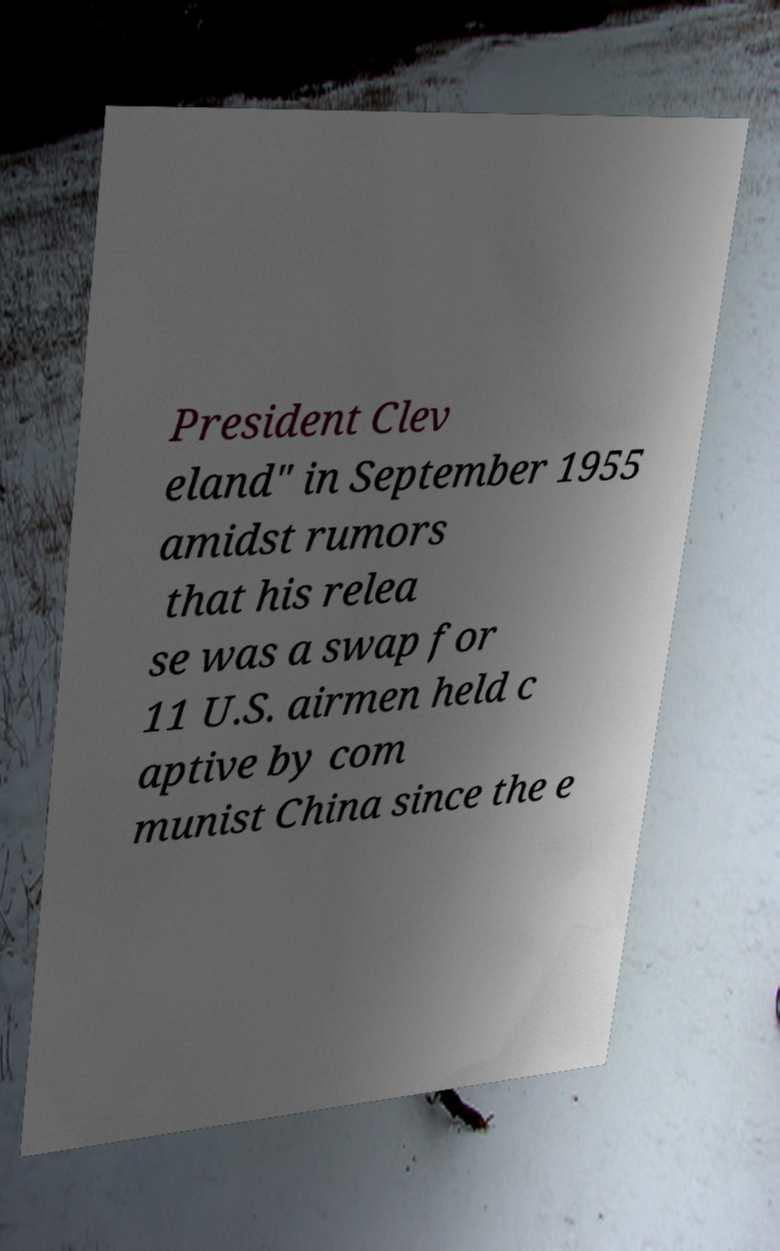There's text embedded in this image that I need extracted. Can you transcribe it verbatim? President Clev eland" in September 1955 amidst rumors that his relea se was a swap for 11 U.S. airmen held c aptive by com munist China since the e 